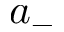Convert formula to latex. <formula><loc_0><loc_0><loc_500><loc_500>a _ { - }</formula> 